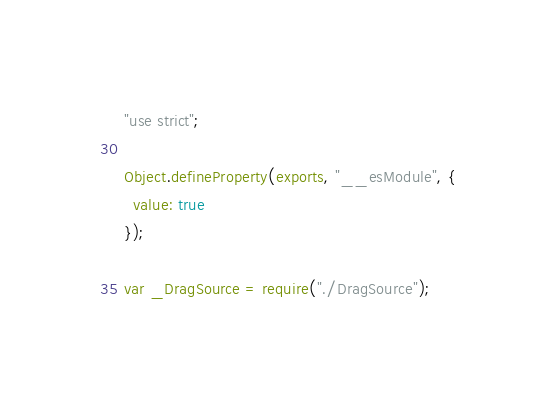<code> <loc_0><loc_0><loc_500><loc_500><_JavaScript_>"use strict";

Object.defineProperty(exports, "__esModule", {
  value: true
});

var _DragSource = require("./DragSource");
</code> 